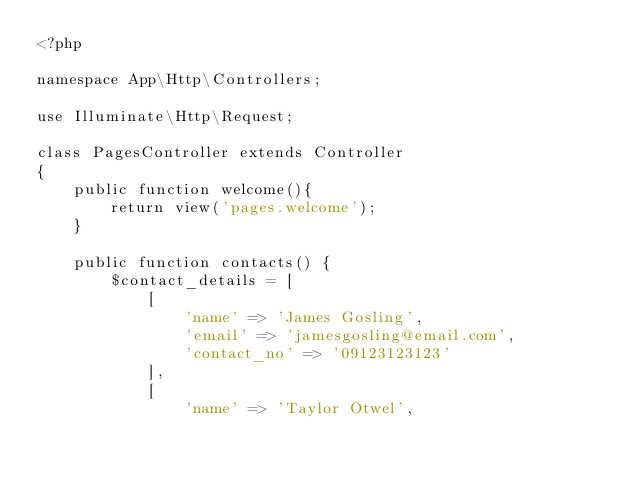Convert code to text. <code><loc_0><loc_0><loc_500><loc_500><_PHP_><?php

namespace App\Http\Controllers;

use Illuminate\Http\Request;

class PagesController extends Controller
{
    public function welcome(){
        return view('pages.welcome');
    }

    public function contacts() {
        $contact_details = [
            [
                'name' => 'James Gosling',
                'email' => 'jamesgosling@email.com',
                'contact_no' => '09123123123'
            ],
            [
                'name' => 'Taylor Otwel',</code> 